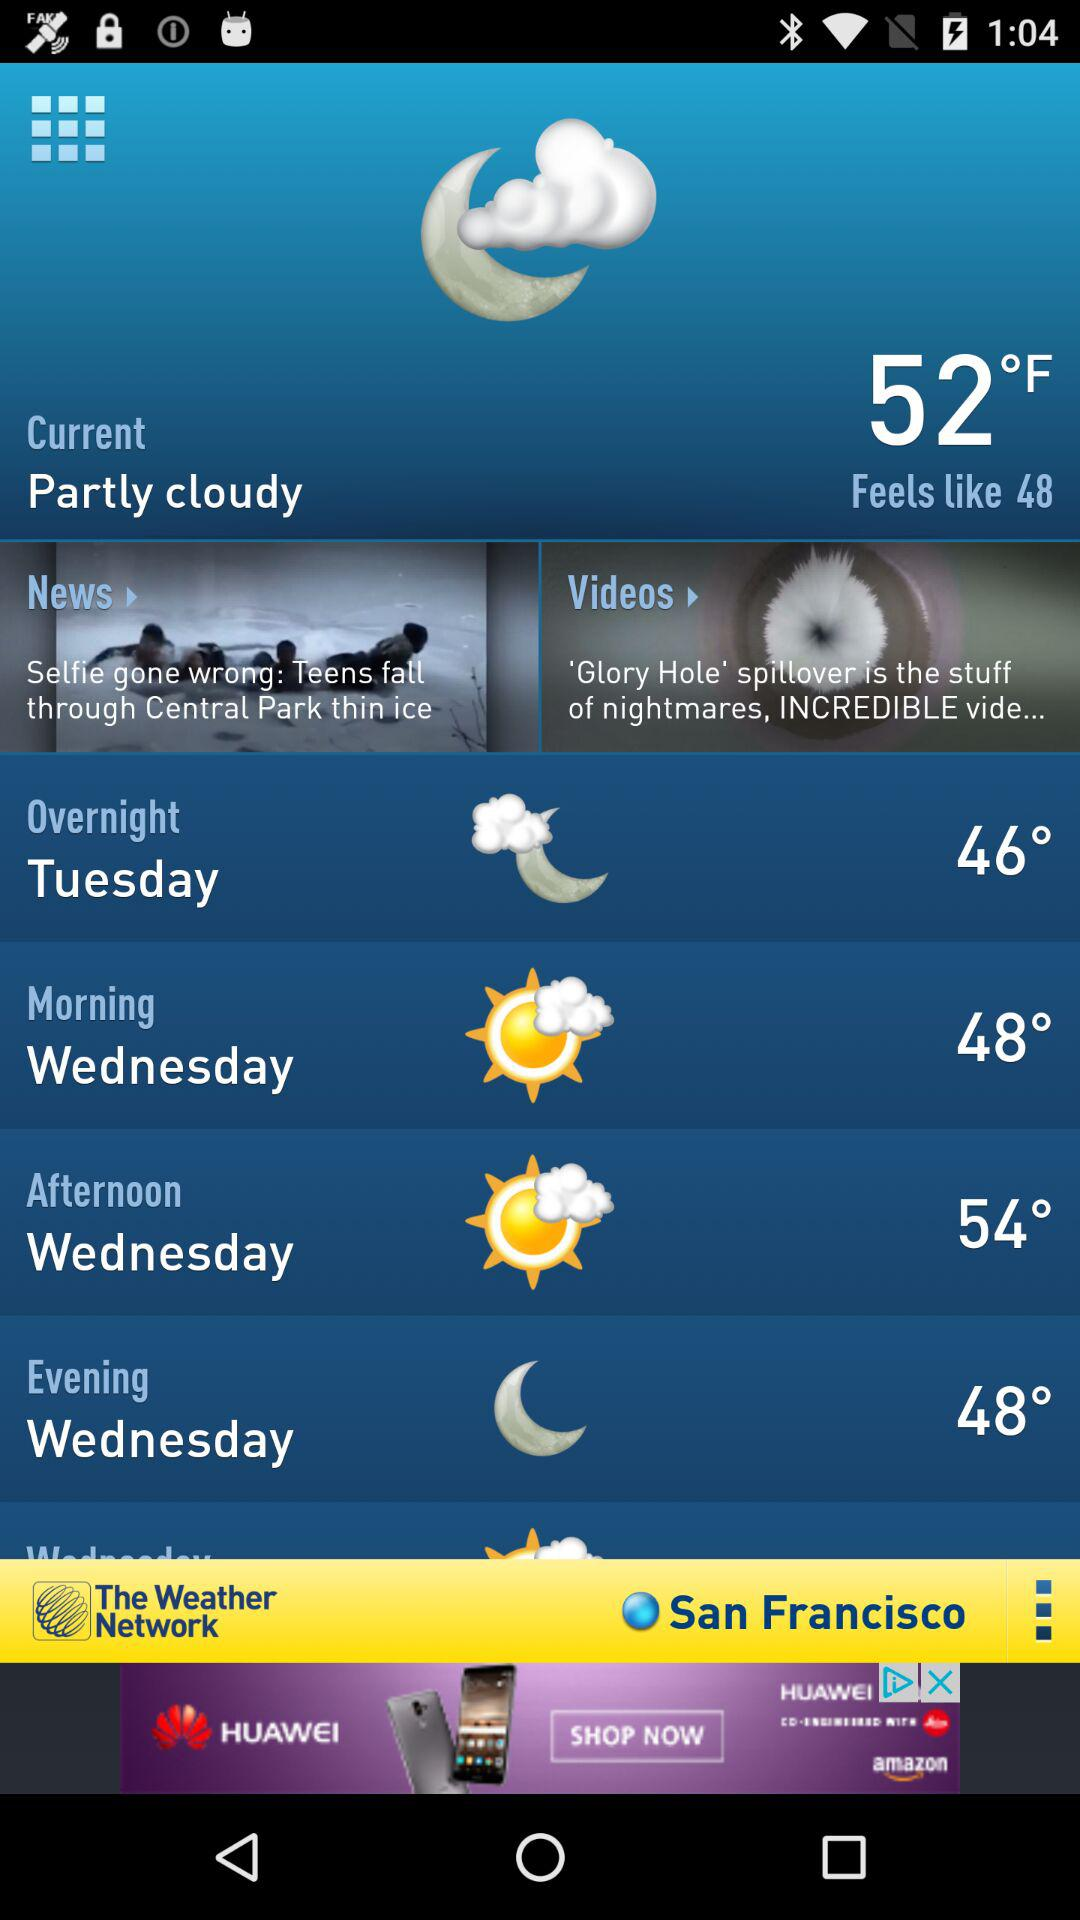What is today's weather forecast? Today's weather is partly cloudy and the temperature is 52 °F. 